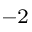Convert formula to latex. <formula><loc_0><loc_0><loc_500><loc_500>^ { - 2 }</formula> 